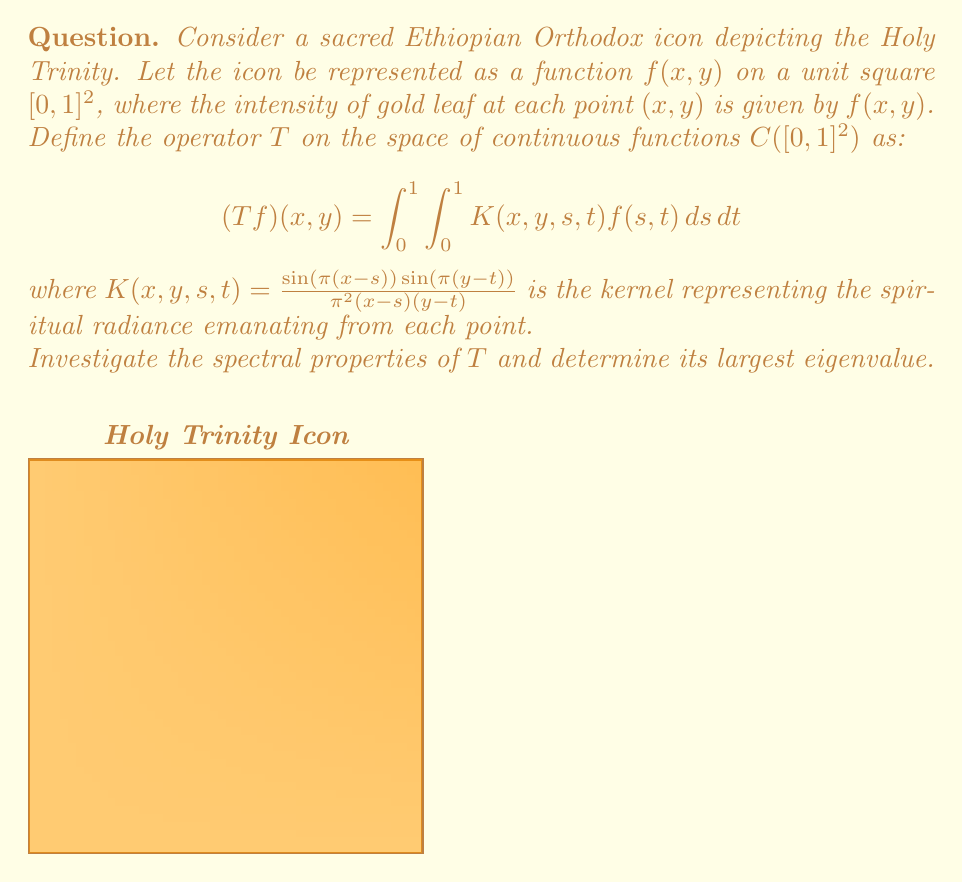Give your solution to this math problem. To investigate the spectral properties of the operator $T$, we need to follow these steps:

1) First, observe that $T$ is a compact integral operator on $C([0,1]^2)$. The kernel $K(x,y,s,t)$ is continuous on $[0,1]^4$, which ensures compactness.

2) The kernel $K(x,y,s,t)$ is symmetric, i.e., $K(x,y,s,t) = K(s,t,x,y)$. This implies that $T$ is self-adjoint.

3) For a compact, self-adjoint operator, the spectral theorem guarantees that its spectrum consists of real eigenvalues that converge to zero (if infinite).

4) To find the eigenvalues, we need to solve the eigenvalue equation:

   $$(Tf)(x,y) = \lambda f(x,y)$$

5) Substituting the definition of $T$:

   $$\int_0^1 \int_0^1 \frac{\sin(\pi(x-s))\sin(\pi(y-t))}{\pi^2(x-s)(y-t)}f(s,t)dsdt = \lambda f(x,y)$$

6) This equation is satisfied by the eigenfunctions:

   $$f_{m,n}(x,y) = \sin(m\pi x)\sin(n\pi y)$$

   where $m,n$ are positive integers.

7) The corresponding eigenvalues are:

   $$\lambda_{m,n} = \frac{1}{mn}$$

8) The largest eigenvalue is therefore $\lambda_{1,1} = 1$, corresponding to the eigenfunction $f_{1,1}(x,y) = \sin(\pi x)\sin(\pi y)$.

This largest eigenvalue represents the most significant mode of spiritual radiance in the icon, corresponding to a single, central focus of divine light.
Answer: $\lambda_{max} = 1$ 